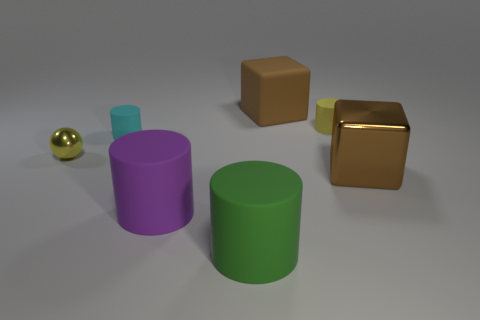What's the texture of the yellow cube in the image? The yellow cube appears to have a smooth, matte finish with an even, consistent coloration, resulting in a simple yet appealing aesthetic. 